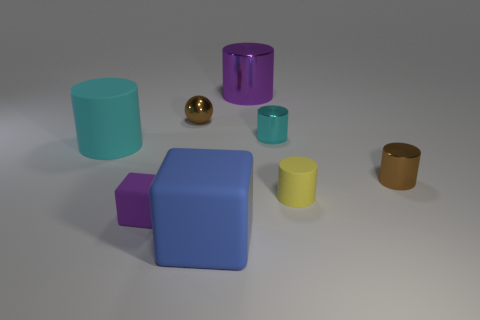There is a blue thing that is made of the same material as the yellow cylinder; what shape is it?
Your response must be concise. Cube. What is the color of the matte cylinder to the right of the large purple metal object that is on the right side of the big cyan thing?
Your answer should be very brief. Yellow. Is the shape of the big cyan matte thing the same as the blue matte object?
Your response must be concise. No. What material is the other cyan object that is the same shape as the cyan matte thing?
Your answer should be very brief. Metal. Are there any objects that are right of the rubber cylinder to the right of the cyan object on the left side of the tiny matte block?
Ensure brevity in your answer.  Yes. There is a large purple shiny object; does it have the same shape as the large object in front of the yellow thing?
Provide a succinct answer. No. Is there any other thing of the same color as the large metallic object?
Give a very brief answer. Yes. There is a large cylinder that is behind the big cyan matte cylinder; is it the same color as the large rubber object behind the brown cylinder?
Your answer should be compact. No. Are there any large matte cylinders?
Give a very brief answer. Yes. Is there another tiny brown cylinder that has the same material as the brown cylinder?
Ensure brevity in your answer.  No. 